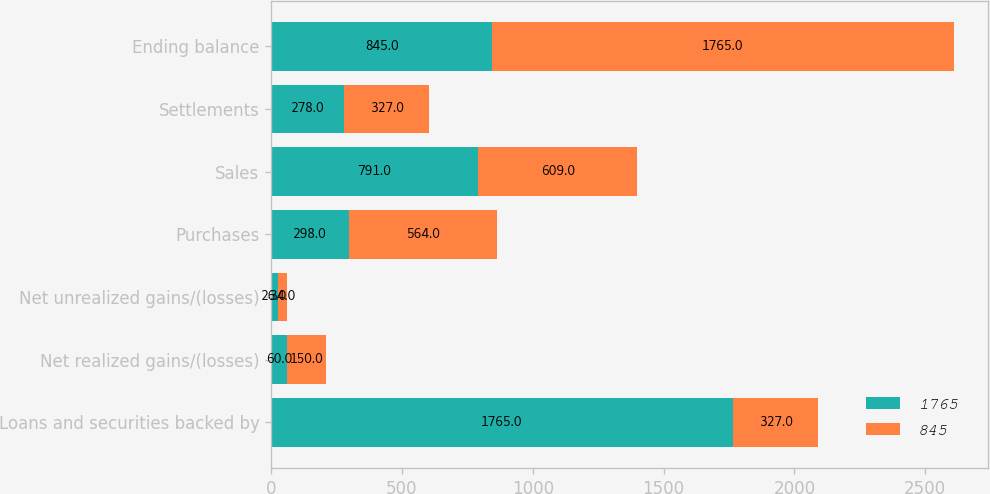Convert chart. <chart><loc_0><loc_0><loc_500><loc_500><stacked_bar_chart><ecel><fcel>Loans and securities backed by<fcel>Net realized gains/(losses)<fcel>Net unrealized gains/(losses)<fcel>Purchases<fcel>Sales<fcel>Settlements<fcel>Ending balance<nl><fcel>1765<fcel>1765<fcel>60<fcel>26<fcel>298<fcel>791<fcel>278<fcel>845<nl><fcel>845<fcel>327<fcel>150<fcel>34<fcel>564<fcel>609<fcel>327<fcel>1765<nl></chart> 